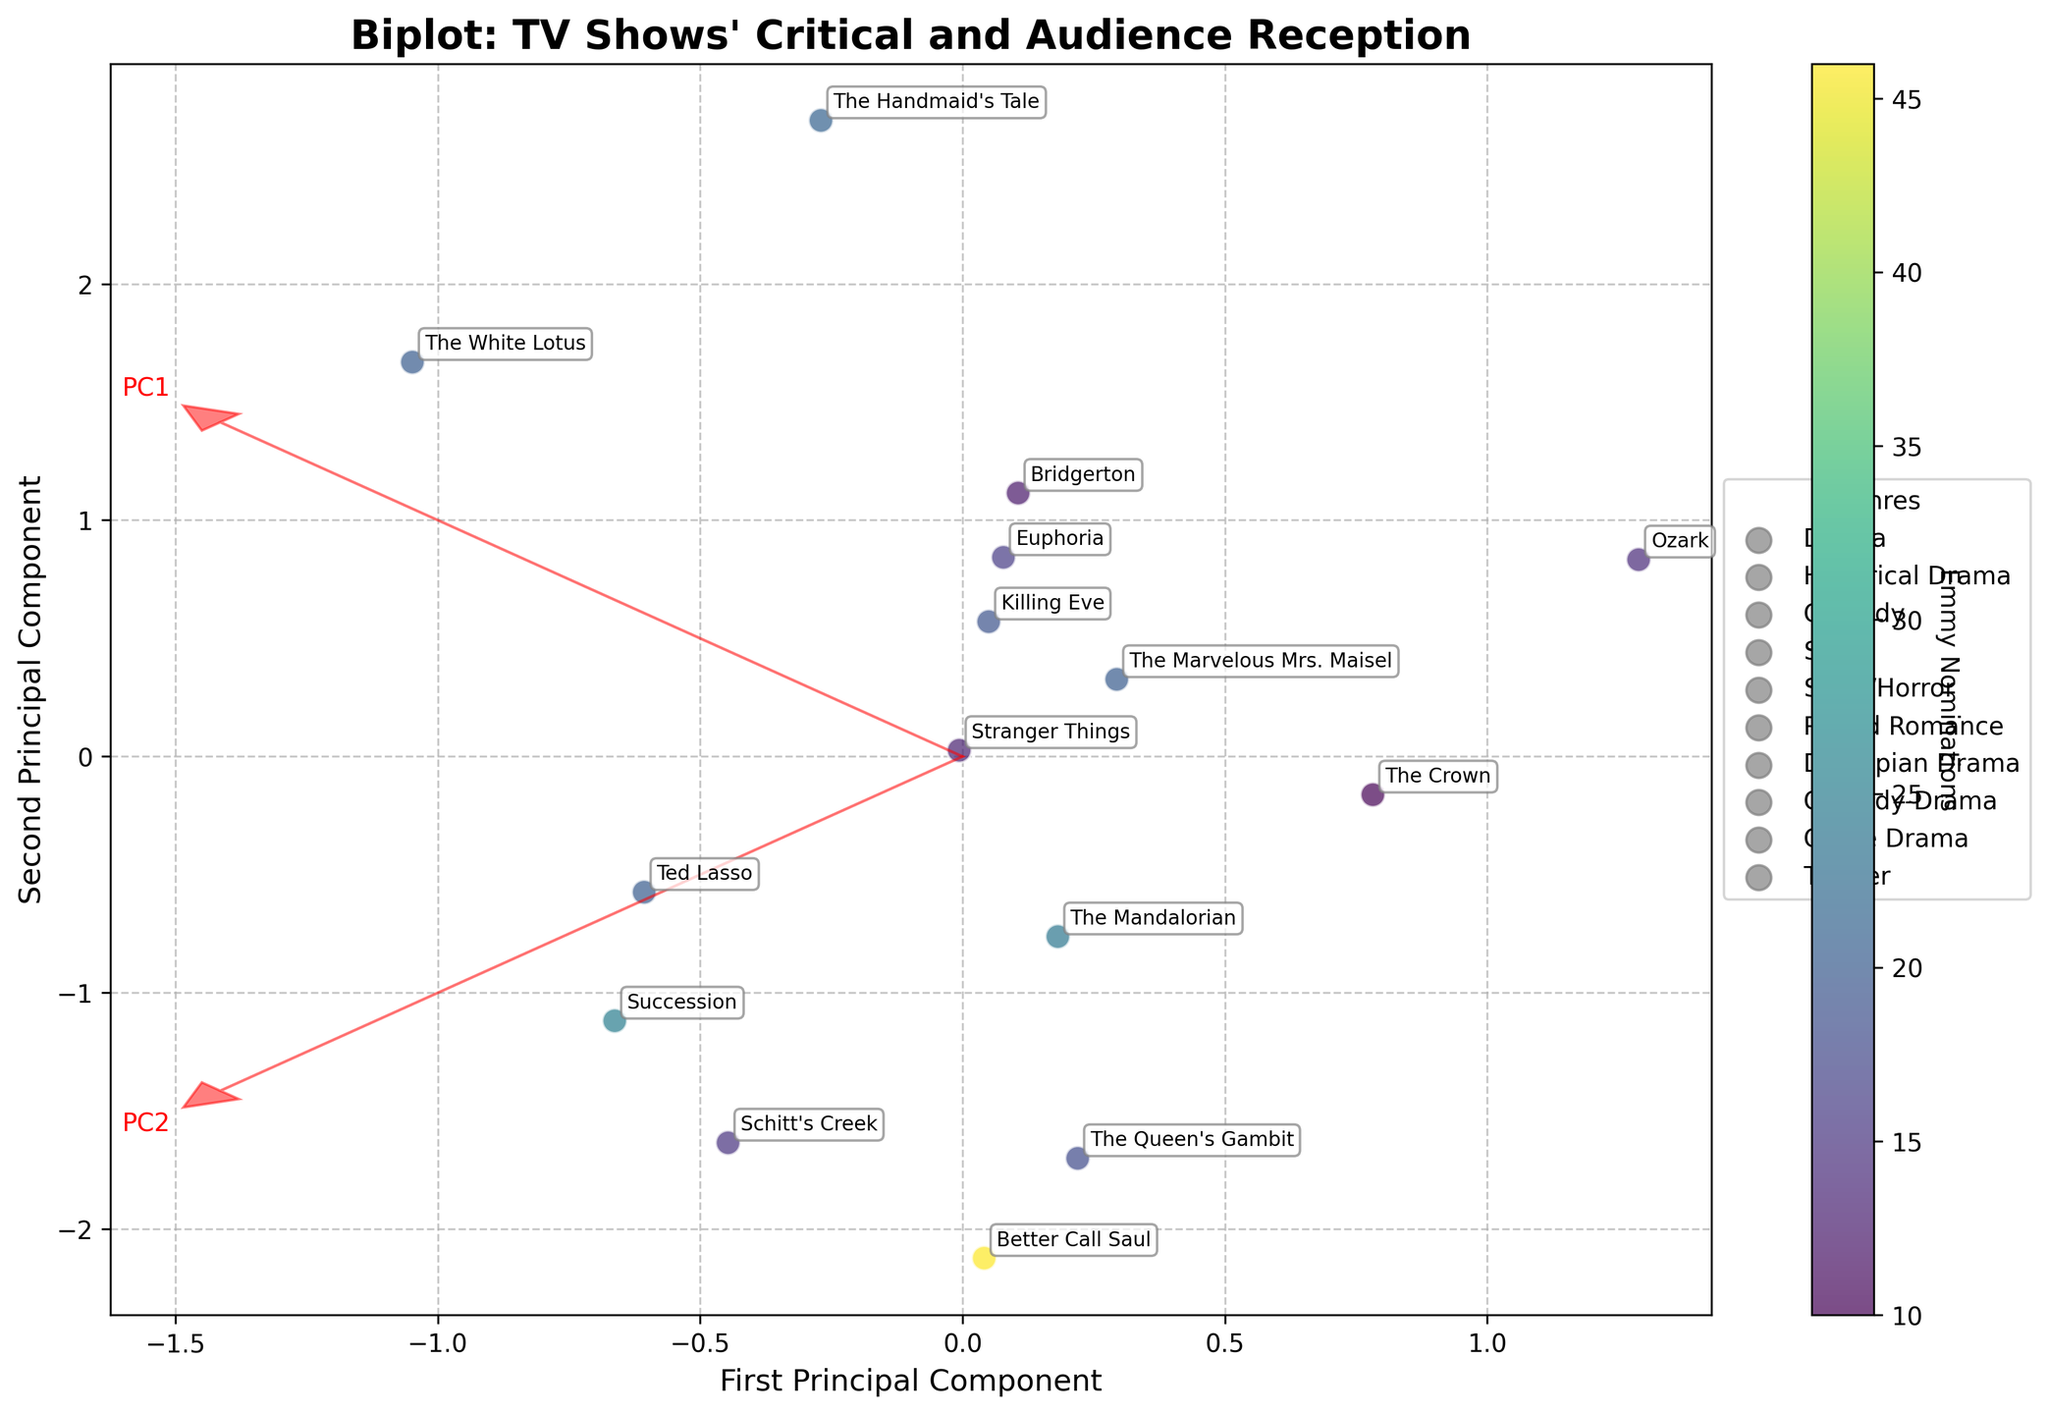Which TV show has the highest critics' score? From the biplot, the TV show positioned furthest along the principal component direction that positively correlates with critics' score represents the highest score.
Answer: Schitt's Creek What are the total Emmy nominations for the shows with the highest and lowest audience scores? The biplot shows that the highest audience score is close to a principal component direction that positively correlates with Better Call Saul, and the lowest with The Handmaid's Tale. Adding their Emmy nominations, Better Call Saul has 46 and The Handmaid's Tale has 21.
Answer: 67 Which genre has the most shows in the biplot? By counting the unique show labels and their associated genres displayed in the legend, Drama appears the most frequently.
Answer: Drama Between Better Call Saul and The Queen's Gambit, which show has a higher combination of critical and audience reception? Observing the plot positions of both shows relative to the arrows representing principal components, Better Call Saul and The Queen's Gambit each align closely. Since both components are crucial here, Better Call Saul edges ahead on overall placement.
Answer: Better Call Saul Are the principal components positively correlated with both critics' and audience scores? The arrows indicating principal components typically align with increasing values for both scores when moving along their directions. Thus, they exhibit positive correlation with the scores.
Answer: Yes Which show is most centrally located relative to the origin? The show positioned nearest to the center of the biplot is closer to the origin in terms of PC values, implying an average reception.
Answer: Euphoria What is the average number of Emmy nominations for the Comedy shows? Summing the Emmy nominations for Comedy shows (Ted Lasso, Schitt's Creek, The Marvelous Mrs. Maisel) gives 20+15+20 = 55, with 3 shows. The average is then 55/3.
Answer: ~18.33 How do critics' and audience scores generally correlate for the Emmy-nominated TV shows? Evaluating the positions of the TV shows along the principal components shows a broad agreement; higher critical scores generally align with high audience scores, implying positive correlation.
Answer: Positively correlated 